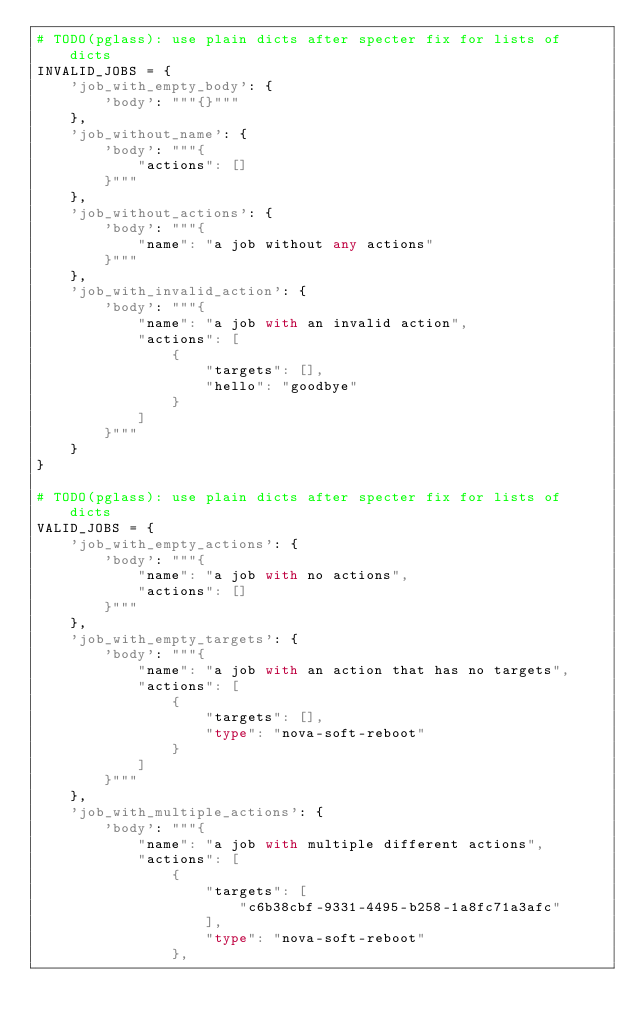<code> <loc_0><loc_0><loc_500><loc_500><_Python_># TODO(pglass): use plain dicts after specter fix for lists of dicts
INVALID_JOBS = {
    'job_with_empty_body': {
        'body': """{}"""
    },
    'job_without_name': {
        'body': """{
            "actions": []
        }"""
    },
    'job_without_actions': {
        'body': """{
            "name": "a job without any actions"
        }"""
    },
    'job_with_invalid_action': {
        'body': """{
            "name": "a job with an invalid action",
            "actions": [
                {
                    "targets": [],
                    "hello": "goodbye"
                }
            ]
        }"""
    }
}

# TODO(pglass): use plain dicts after specter fix for lists of dicts
VALID_JOBS = {
    'job_with_empty_actions': {
        'body': """{
            "name": "a job with no actions",
            "actions": []
        }"""
    },
    'job_with_empty_targets': {
        'body': """{
            "name": "a job with an action that has no targets",
            "actions": [
                {
                    "targets": [],
                    "type": "nova-soft-reboot"
                }
            ]
        }"""
    },
    'job_with_multiple_actions': {
        'body': """{
            "name": "a job with multiple different actions",
            "actions": [
                {
                    "targets": [
                        "c6b38cbf-9331-4495-b258-1a8fc71a3afc"
                    ],
                    "type": "nova-soft-reboot"
                },</code> 